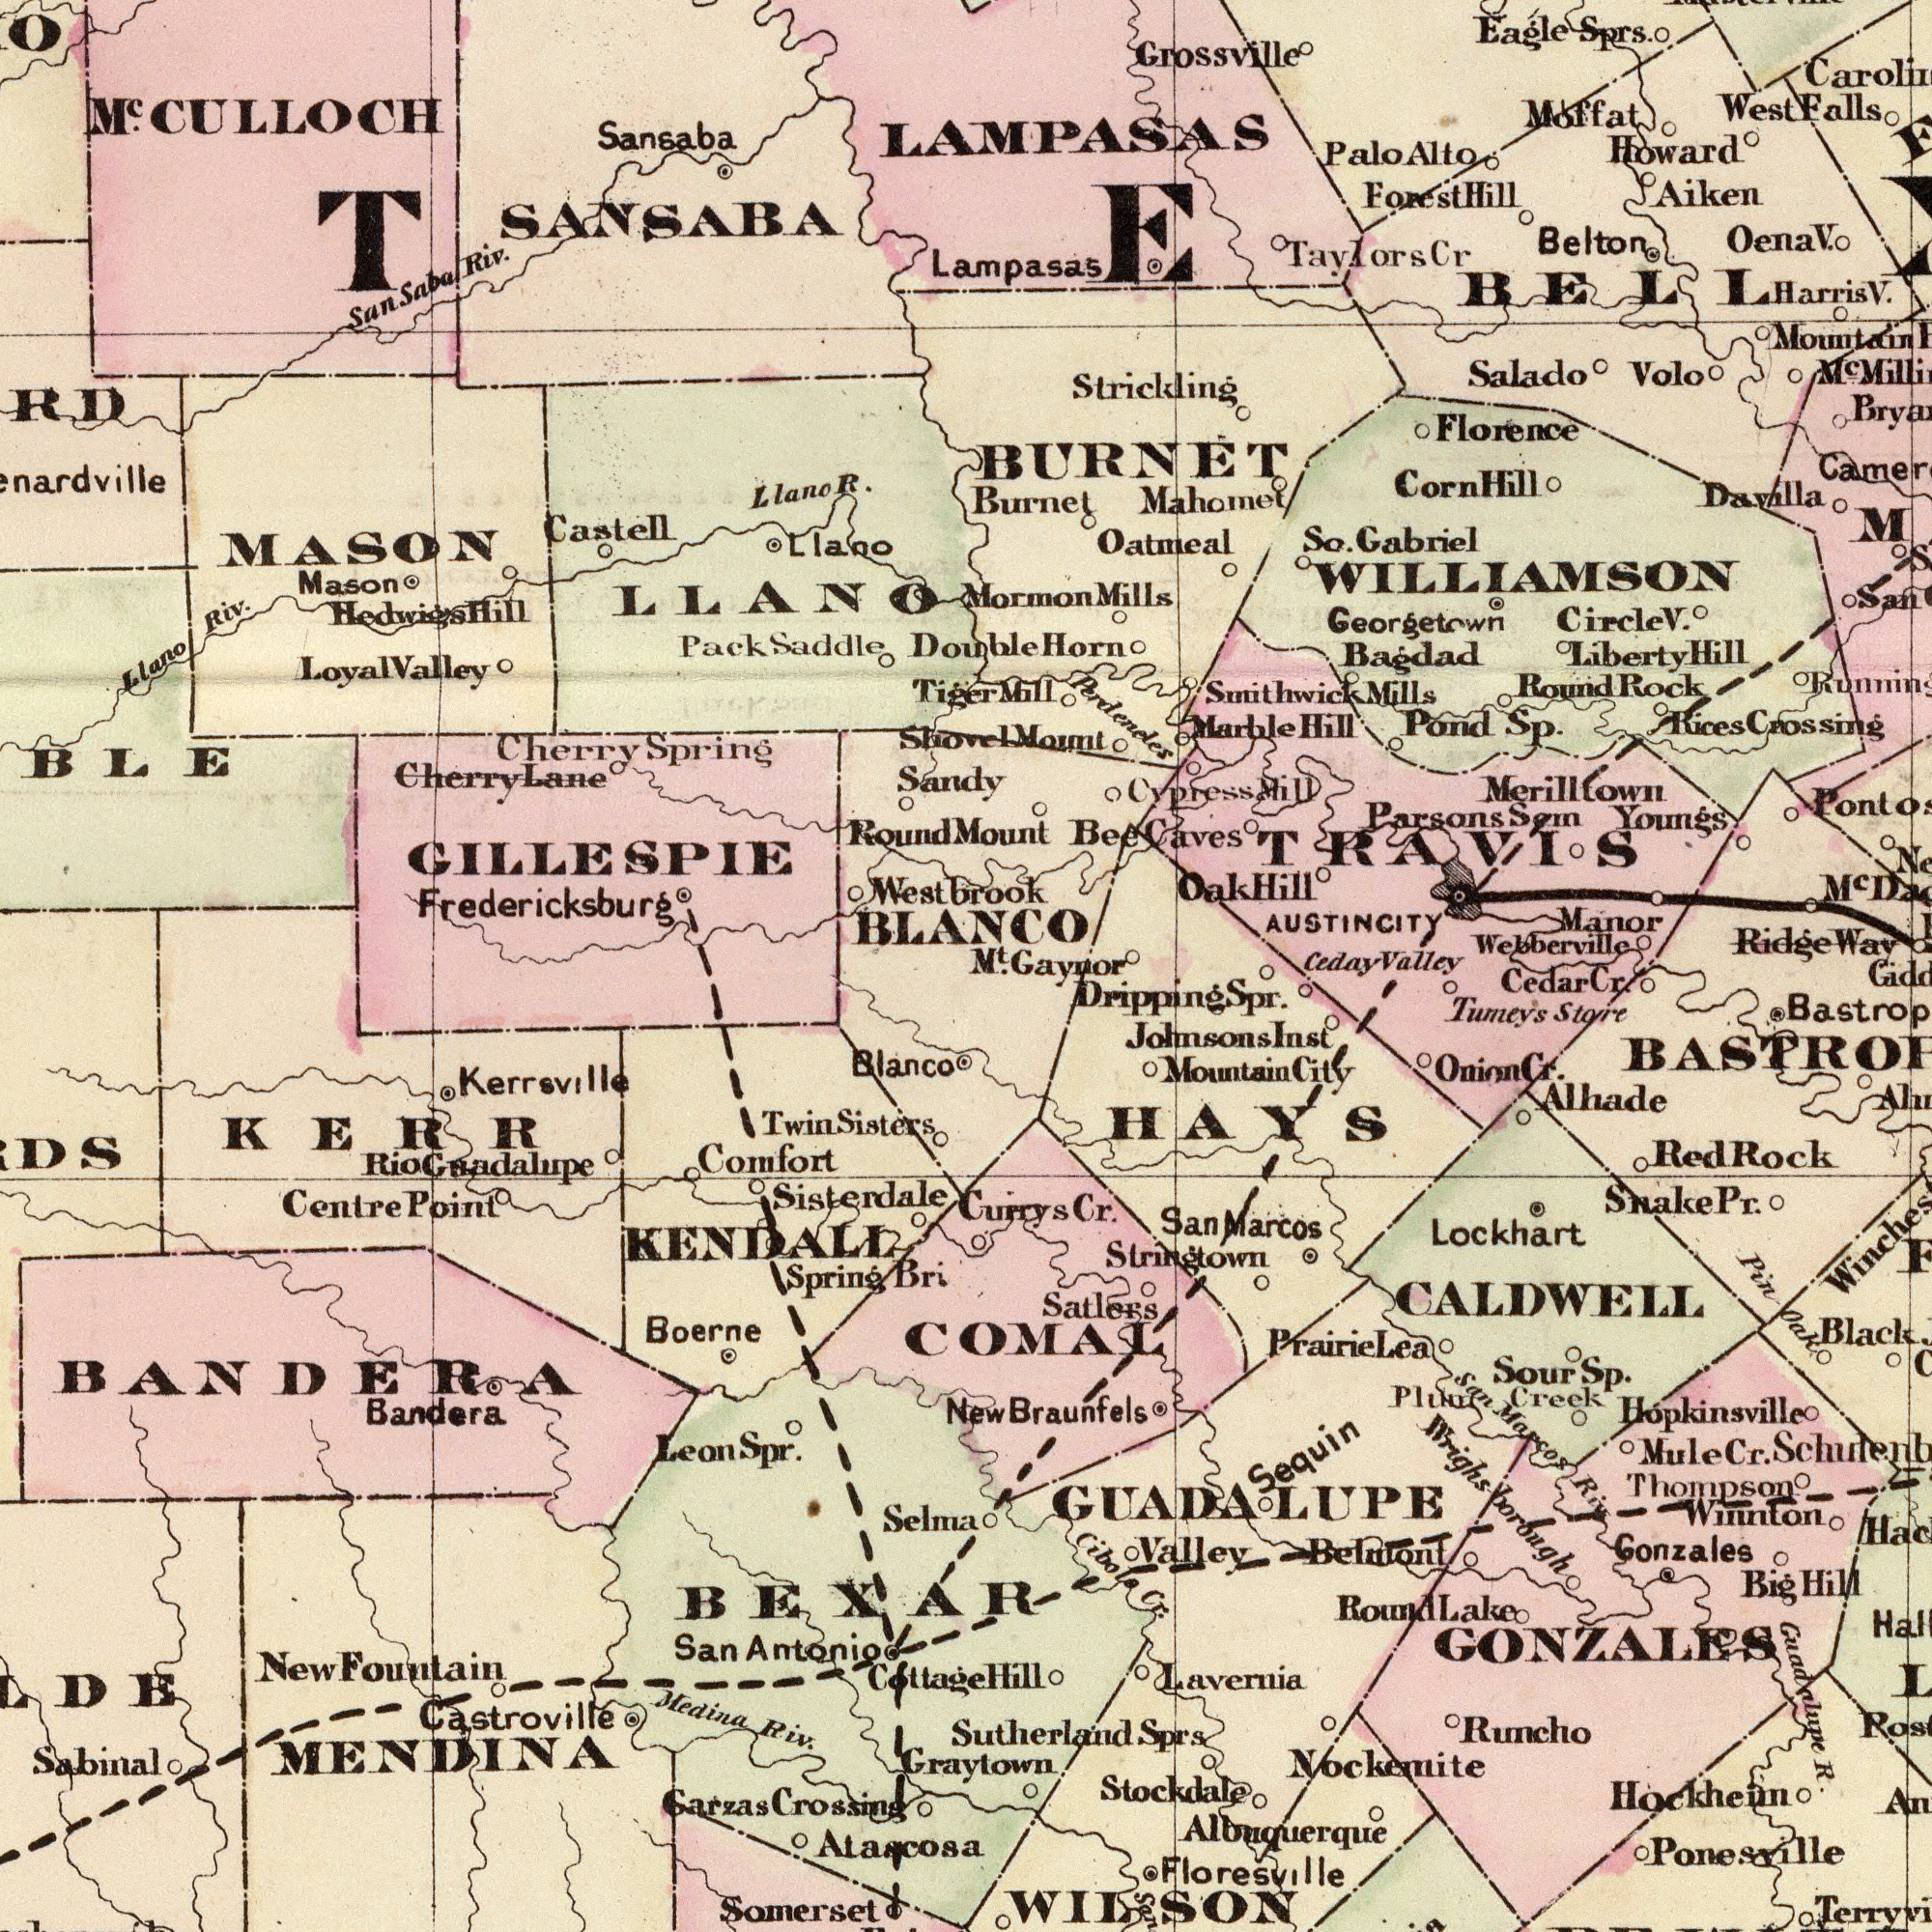What text can you see in the top-right section? Strickling Bagdad Mahomet Georgetown Circle Grossville Oena Oatmeal Moffat Gabriel Salado Davilla Florence Perdeneles AUSTINCITY Merilltown Youngs Round Burnet Belton Mountain Way Pond Manor So. Rock LAMPASAS Smithwick Eagle Hill Mill Ridge Harris Aiken Lampasas Forest Marble Mount BURNET West Caves Horn Sprs. Howard Sp. Mills Corn Mount Volo Webberville Crossing BELL Palo Rices San Mills Taylors Hill Bee Cypress Mormon WILLIAMSON Mill TRAVIS Parsons Hill Hill Liberty Sem Oak M<sup>t</sup>. Gaynor Ceday Valley Alto Hill Falls Cr V. V. M<sup>c</sup>. M<sup>c</sup> V. What text is visible in the lower-right corner? Nockemite Hopkinsville Ponesville Tumeys COMAL Stockdale Black Braunfels Onion Gonzales Store Belmont Creek Runcho Alhade Hockheim R. GONZALES HAYS Lavernia Currys Floresville Winnton Valley Sequin Cr. Lockhart Cibole Albuquerque Snake Sour Pin- Prairie Johnsons Riv Mountain Big Hill City Sprs Graytown Guadnlupe Wrighs-borough Marcos Sp. Dripping Mule Stringtown Thompson Cr. Oak Plum New Round Satlers WILSON CALDWELL Hill Cedar Spr. Sutherland San Marcos Rock GUADALUPE Red Pr. Cr. Lake San Cr. Inst Cr. Lea What text is visible in the lower-left corner? Castroville Sabinal Bandera Kerrsville Bri Atascosa Centre Boerne Antonio Blanco Cottage Sisterdale Medina San Crossing Point Riv. Sisters Garzas Fountain Spring Selma Comfort MENDINA New Somerset BANDERA Guadalupe Spr. Twin KENDALL KERR BEXAR Leon Rio What text is shown in the top-left quadrant? MASON Sansaba Castell Saddle Riv. Pack BLANCO Fredericksburg Cherry Westbrook Llano Riv. R. Mason Spring Shovel LLANO Llano Round M<sup>c</sup>. Tiger Cherry Sandy Lane Saba SANSABA GILLESPIE Hill CULLOCH Hedwigs Valley Loyal Llano San Double 